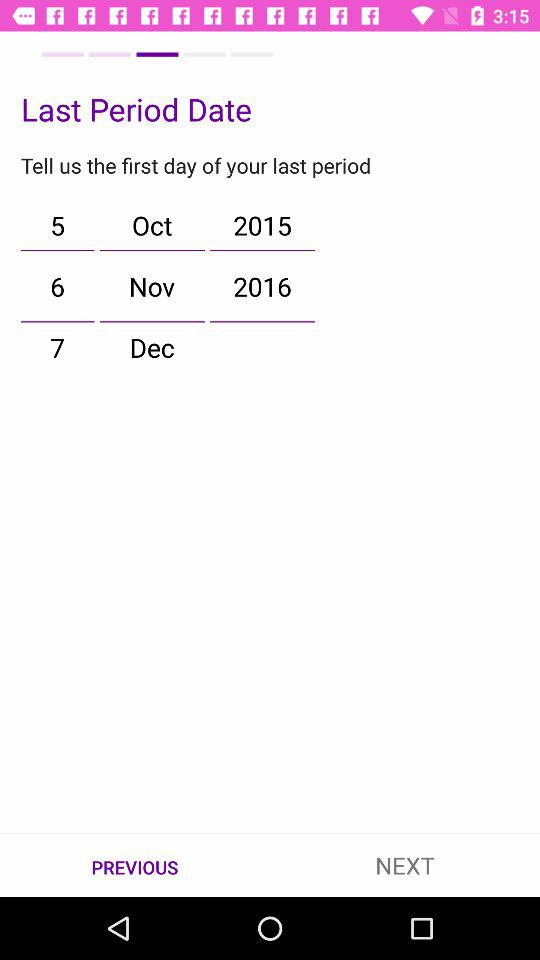What is the selected date?
When the provided information is insufficient, respond with <no answer>. <no answer> 